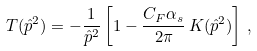Convert formula to latex. <formula><loc_0><loc_0><loc_500><loc_500>T ( \hat { p } ^ { 2 } ) = - \frac { 1 } { \hat { p } ^ { 2 } } \left [ 1 - \frac { C _ { F } \alpha _ { s } } { 2 \pi } \, K ( \hat { p } ^ { 2 } ) \right ] \, ,</formula> 